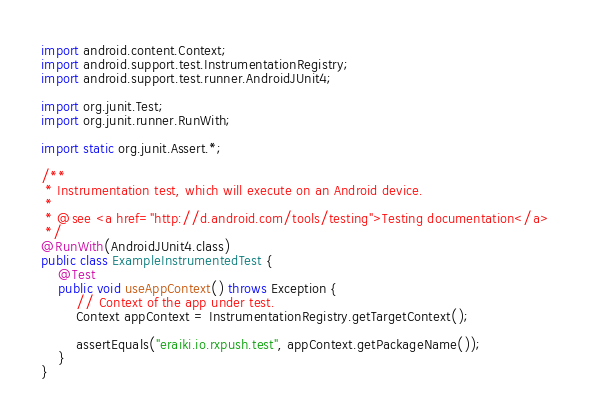Convert code to text. <code><loc_0><loc_0><loc_500><loc_500><_Java_>import android.content.Context;
import android.support.test.InstrumentationRegistry;
import android.support.test.runner.AndroidJUnit4;

import org.junit.Test;
import org.junit.runner.RunWith;

import static org.junit.Assert.*;

/**
 * Instrumentation test, which will execute on an Android device.
 *
 * @see <a href="http://d.android.com/tools/testing">Testing documentation</a>
 */
@RunWith(AndroidJUnit4.class)
public class ExampleInstrumentedTest {
    @Test
    public void useAppContext() throws Exception {
        // Context of the app under test.
        Context appContext = InstrumentationRegistry.getTargetContext();

        assertEquals("eraiki.io.rxpush.test", appContext.getPackageName());
    }
}
</code> 